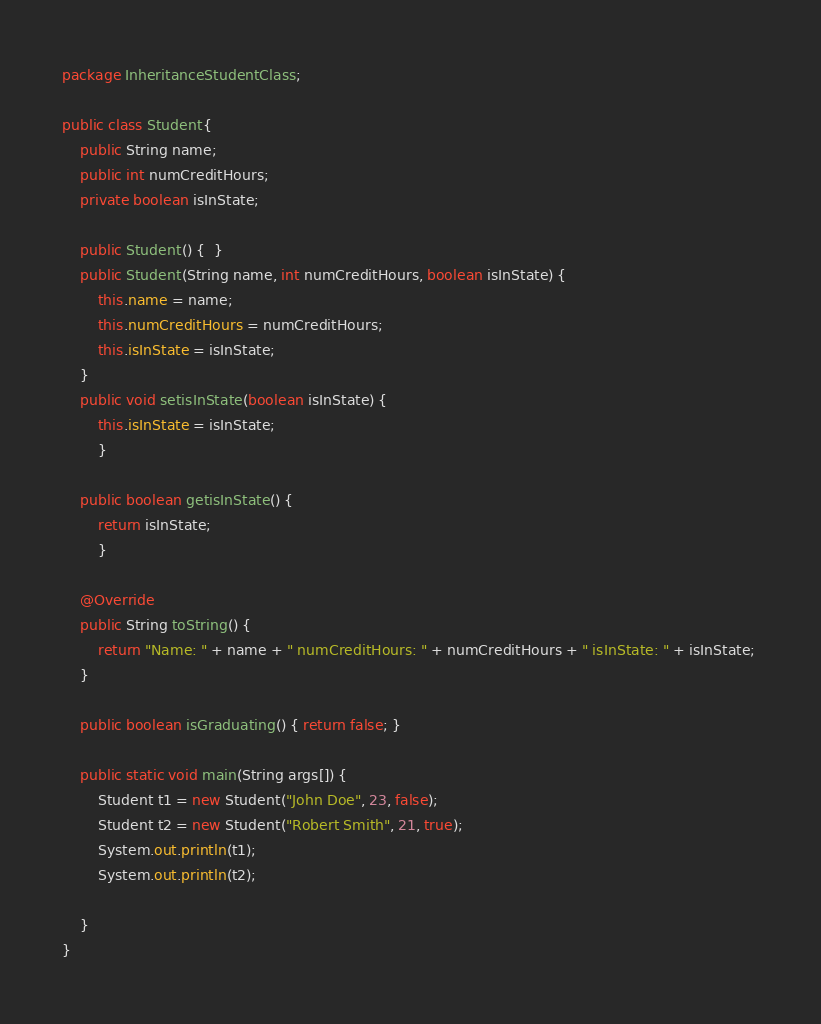Convert code to text. <code><loc_0><loc_0><loc_500><loc_500><_Java_>package InheritanceStudentClass;

public class Student{
	public String name; 
	public int numCreditHours; 
	private boolean isInState;
	
	public Student() {  } 
	public Student(String name, int numCreditHours, boolean isInState) {
		this.name = name; 
		this.numCreditHours = numCreditHours;
		this.isInState = isInState; 
	} 
	public void setisInState(boolean isInState) { 
		this.isInState = isInState; 
		} 
	
	public boolean getisInState() { 
		return isInState; 
		} 
	
	@Override
	public String toString() { 
		return "Name: " + name + " numCreditHours: " + numCreditHours + " isInState: " + isInState; 
	} 

	public boolean isGraduating() { return false; }
	
	public static void main(String args[]) {
		Student t1 = new Student("John Doe", 23, false);
		Student t2 = new Student("Robert Smith", 21, true);
		System.out.println(t1); 
		System.out.println(t2);

	} 
}
</code> 